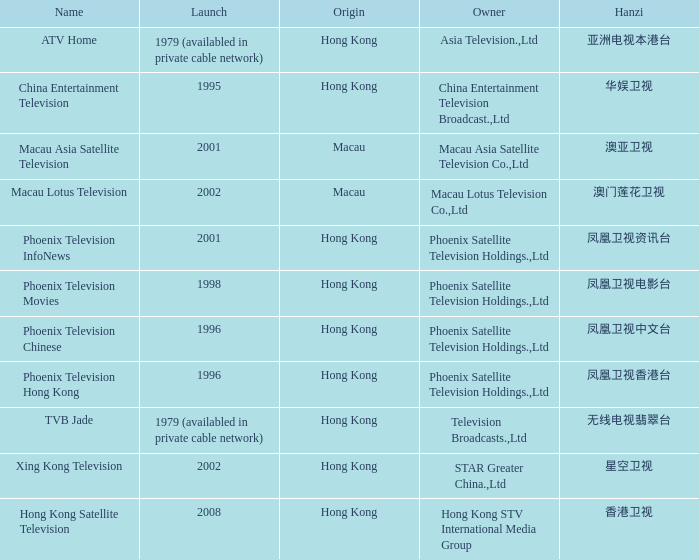Would you be able to parse every entry in this table? {'header': ['Name', 'Launch', 'Origin', 'Owner', 'Hanzi'], 'rows': [['ATV Home', '1979 (availabled in private cable network)', 'Hong Kong', 'Asia Television.,Ltd', '亚洲电视本港台'], ['China Entertainment Television', '1995', 'Hong Kong', 'China Entertainment Television Broadcast.,Ltd', '华娱卫视'], ['Macau Asia Satellite Television', '2001', 'Macau', 'Macau Asia Satellite Television Co.,Ltd', '澳亚卫视'], ['Macau Lotus Television', '2002', 'Macau', 'Macau Lotus Television Co.,Ltd', '澳门莲花卫视'], ['Phoenix Television InfoNews', '2001', 'Hong Kong', 'Phoenix Satellite Television Holdings.,Ltd', '凤凰卫视资讯台'], ['Phoenix Television Movies', '1998', 'Hong Kong', 'Phoenix Satellite Television Holdings.,Ltd', '凤凰卫视电影台'], ['Phoenix Television Chinese', '1996', 'Hong Kong', 'Phoenix Satellite Television Holdings.,Ltd', '凤凰卫视中文台'], ['Phoenix Television Hong Kong', '1996', 'Hong Kong', 'Phoenix Satellite Television Holdings.,Ltd', '凤凰卫视香港台'], ['TVB Jade', '1979 (availabled in private cable network)', 'Hong Kong', 'Television Broadcasts.,Ltd', '无线电视翡翠台'], ['Xing Kong Television', '2002', 'Hong Kong', 'STAR Greater China.,Ltd', '星空卫视'], ['Hong Kong Satellite Television', '2008', 'Hong Kong', 'Hong Kong STV International Media Group', '香港卫视']]} What is the Hanzi of Phoenix Television Chinese that launched in 1996? 凤凰卫视中文台. 